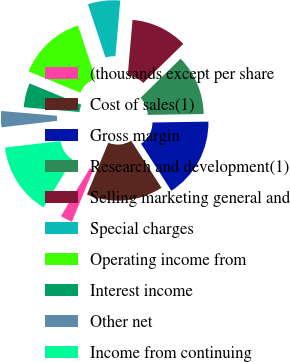Convert chart. <chart><loc_0><loc_0><loc_500><loc_500><pie_chart><fcel>(thousands except per share<fcel>Cost of sales(1)<fcel>Gross margin<fcel>Research and development(1)<fcel>Selling marketing general and<fcel>Special charges<fcel>Operating income from<fcel>Interest income<fcel>Other net<fcel>Income from continuing<nl><fcel>2.42%<fcel>15.32%<fcel>16.13%<fcel>12.1%<fcel>11.29%<fcel>6.45%<fcel>13.71%<fcel>4.84%<fcel>3.23%<fcel>14.52%<nl></chart> 